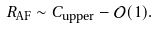<formula> <loc_0><loc_0><loc_500><loc_500>R _ { \text {AF} } \sim C _ { \text {upper} } - \mathcal { O } ( 1 ) .</formula> 